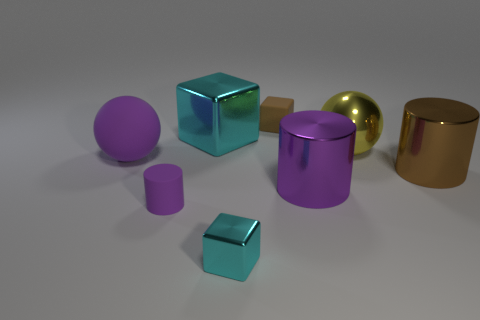Subtract all small cyan metal blocks. How many blocks are left? 2 Subtract all cylinders. How many objects are left? 5 Add 7 brown metal things. How many brown metal things are left? 8 Add 5 big metallic cylinders. How many big metallic cylinders exist? 7 Add 2 large metallic blocks. How many objects exist? 10 Subtract all brown cubes. How many cubes are left? 2 Subtract 1 purple spheres. How many objects are left? 7 Subtract 1 spheres. How many spheres are left? 1 Subtract all yellow balls. Subtract all red cylinders. How many balls are left? 1 Subtract all green spheres. How many cyan cubes are left? 2 